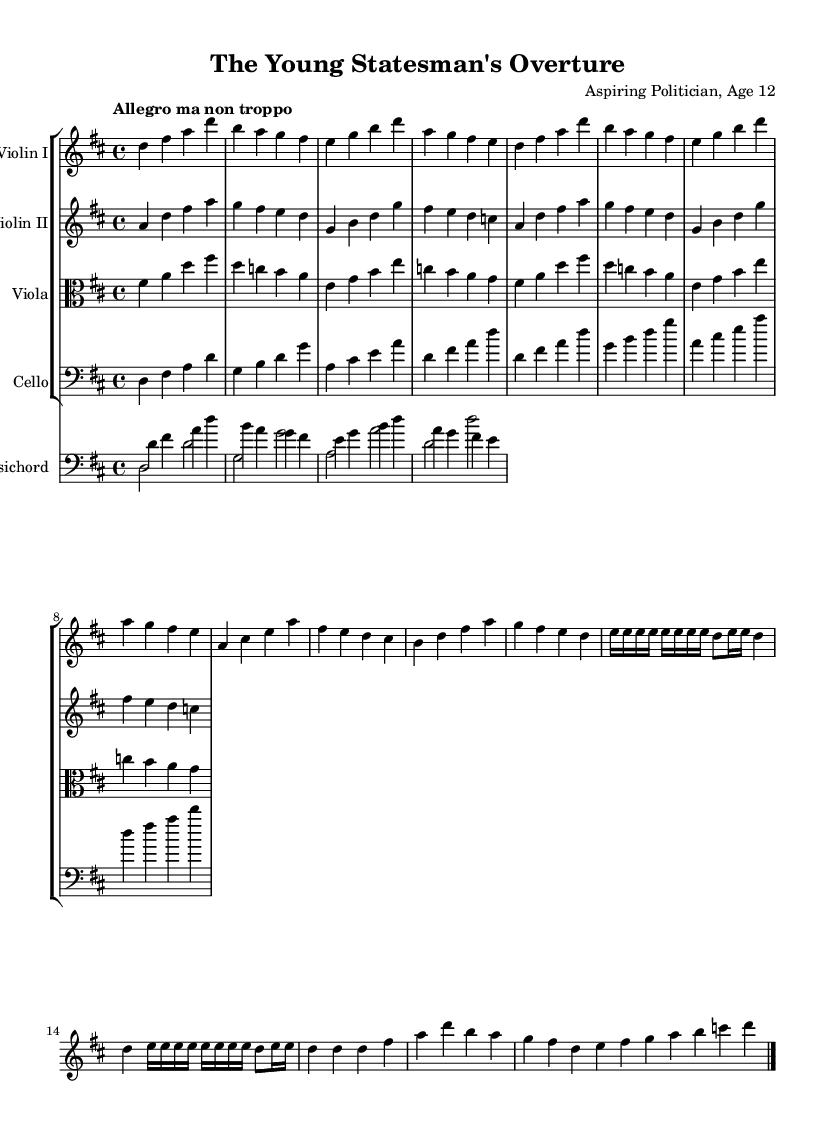What is the key signature of this music? The key signature has two sharps (F# and C#), indicating that the piece is in D major.
Answer: D major What is the time signature of this music? The time signature shown in the music is 4/4, meaning there are four beats in each measure.
Answer: 4/4 What is the tempo marking for this piece? The tempo marking indicates "Allegro ma non troppo," which means to play fast but not too fast.
Answer: Allegro ma non troppo Identify the main theme section labeled in the music. The section labeled "Theme A (Opening Statement)" presents the primary musical material or argument of the piece.
Answer: Theme A How many times is the debate section repeated? The development section labeled "Debate" is repeated two times, which allows for exploration of musical ideas.
Answer: 2 What is the purpose of the cadenza in this piece? The cadenza provides a moment for the musicians to showcase their skills with a free-form passage, typically at the end, enhancing the dramatic closure of the argument.
Answer: Closing Argument What type of musical structure is primarily used in this piece? The piece follows a structured form, typically found in Baroque chamber music, characterized by exposition, development, and recapitulation.
Answer: Exposition, development, recapitulation 